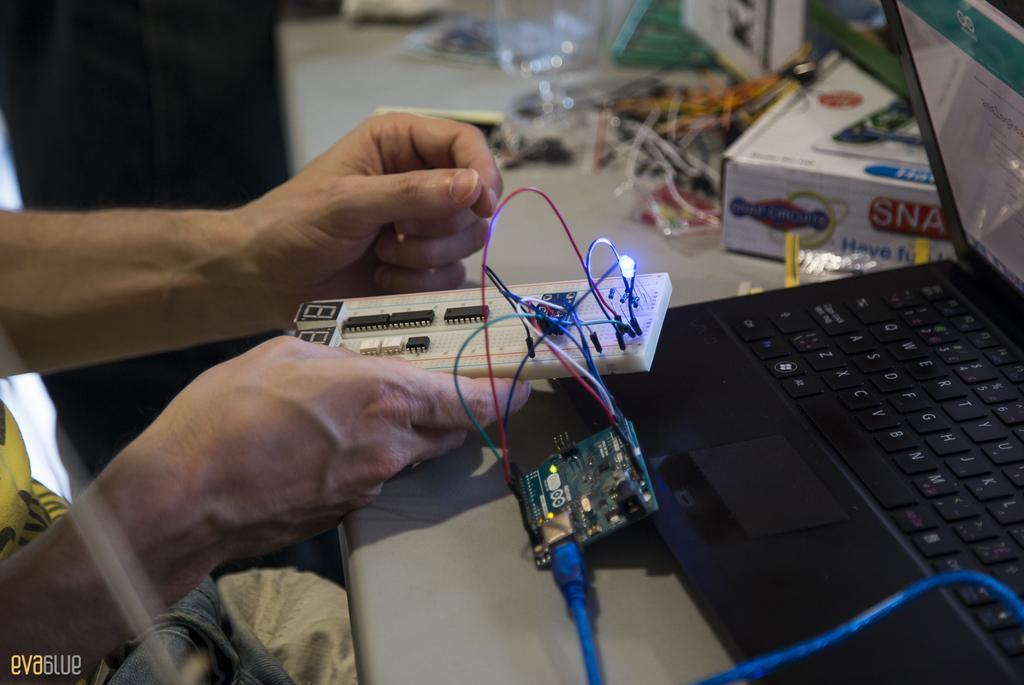How would you summarize this image in a sentence or two? In this image, there is a table contains contains laptop and and box. There is a hand in the middle of the image holding a circuit board. 